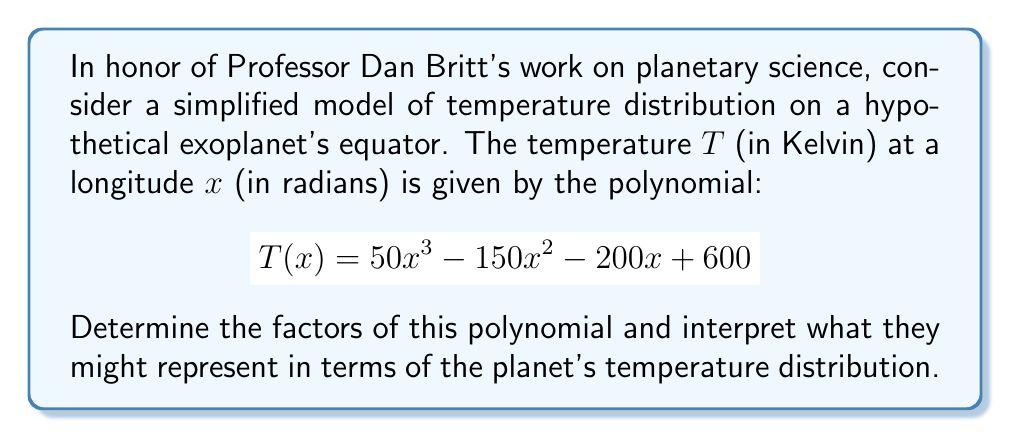Provide a solution to this math problem. To factor this polynomial, we'll follow these steps:

1) First, let's check if there are any common factors. In this case, there are none.

2) Next, we'll try to find the roots of the polynomial. We can use the rational root theorem to find potential rational roots. The potential rational roots are the factors of the constant term (600): ±1, ±2, ±3, ±4, ±5, ±6, ±10, ±12, ±15, ±20, ±25, ±30, ±50, ±60, ±100, ±150, ±200, ±300, ±600.

3) Testing these values, we find that $x = 4$ is a root. So $(x - 4)$ is a factor.

4) Dividing the original polynomial by $(x - 4)$:

   $$(50x^3 - 150x^2 - 200x + 600) \div (x - 4) = 50x^2 + 50x - 150$$

5) Now we have a quadratic equation: $50x^2 + 50x - 150$

6) We can factor this using the quadratic formula or by inspection. By inspection, we can see that this factors to:

   $$50(x^2 + x - 3) = 50(x + 3)(x - 2)$$

7) Therefore, the complete factorization is:

   $$T(x) = 50(x - 4)(x + 3)(x - 2)$$

Interpretation:
- The factor $(x - 4)$ suggests a temperature minimum or maximum at 4 radians (about 229°) longitude.
- The factor $(x + 3)$ suggests another critical point at -3 radians (about -172°) longitude.
- The factor $(x - 2)$ suggests a third critical point at 2 radians (about 115°) longitude.
- The factor 50 scales the overall temperature range.

These points could represent locations of significant geological features, atmospheric phenomena, or day/night transitions that affect the planet's temperature distribution.
Answer: $$T(x) = 50(x - 4)(x + 3)(x - 2)$$ 